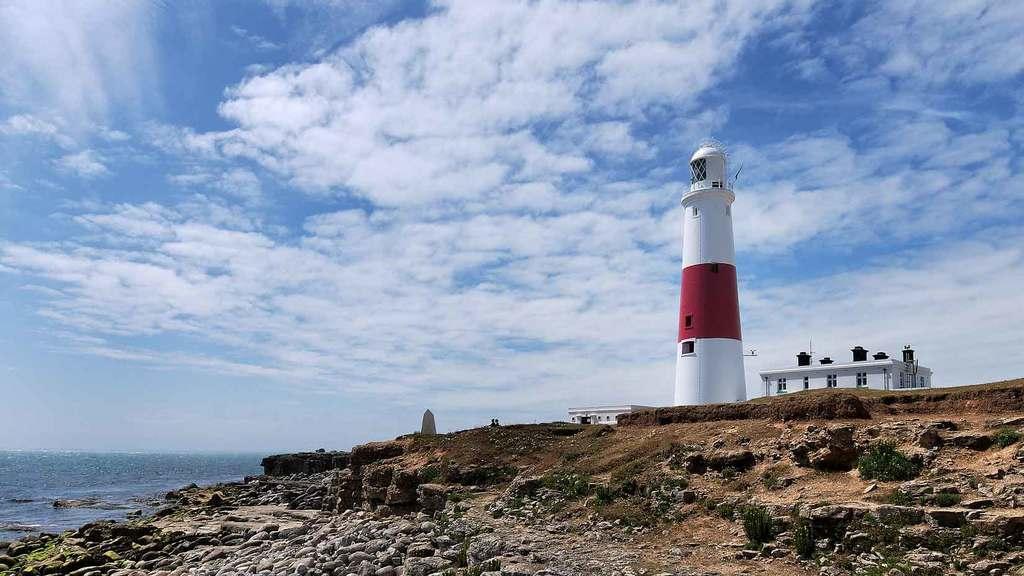Please provide a concise description of this image. On the right side of the image we can see a lighthouse and a building. On the left there is water. At the bottom we can see rocks. In the background there is sky. 